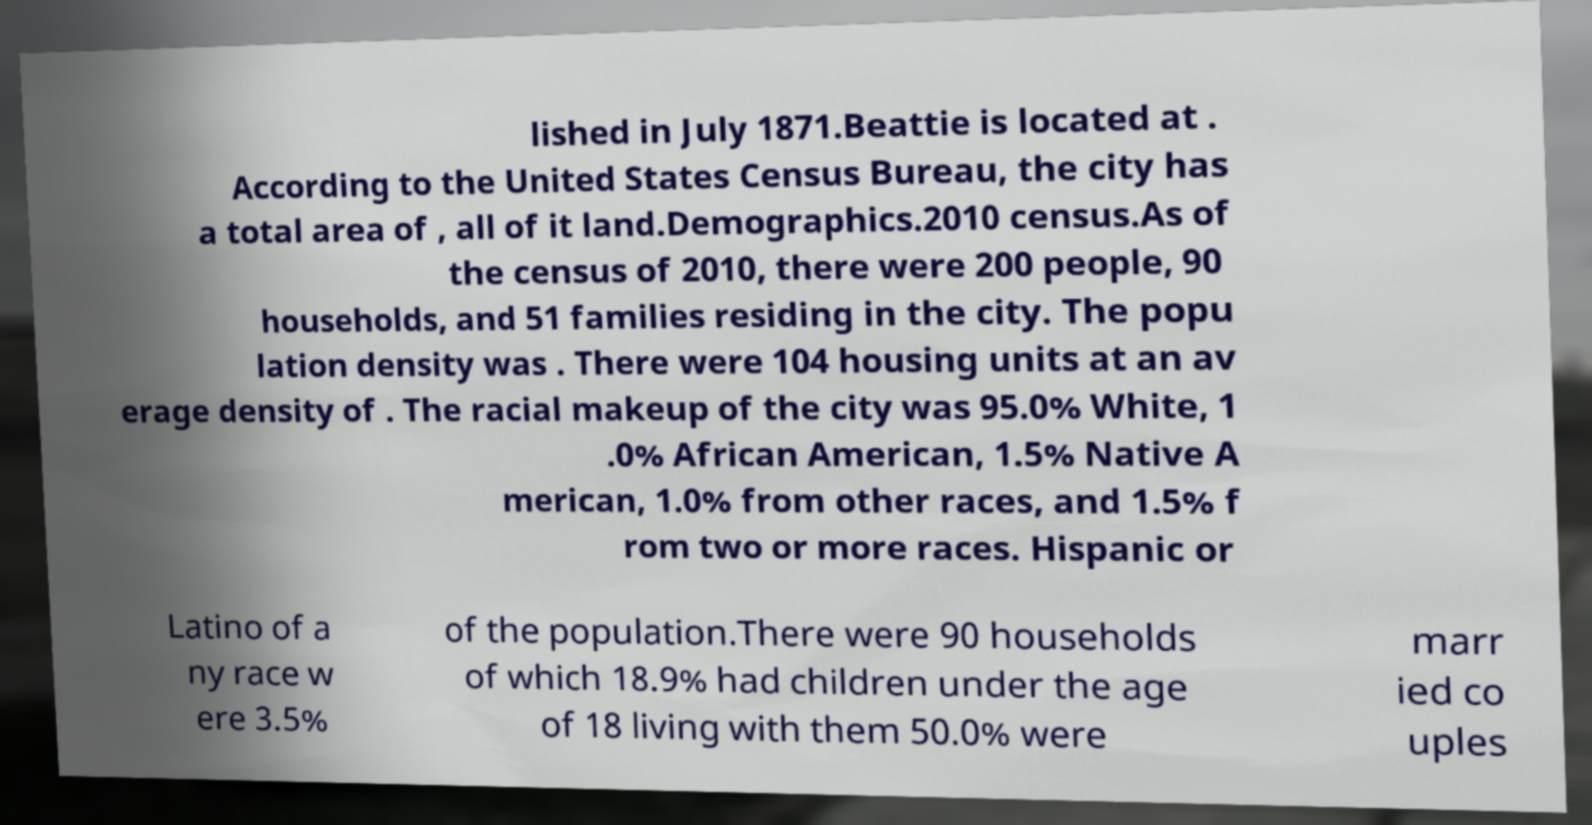Could you extract and type out the text from this image? lished in July 1871.Beattie is located at . According to the United States Census Bureau, the city has a total area of , all of it land.Demographics.2010 census.As of the census of 2010, there were 200 people, 90 households, and 51 families residing in the city. The popu lation density was . There were 104 housing units at an av erage density of . The racial makeup of the city was 95.0% White, 1 .0% African American, 1.5% Native A merican, 1.0% from other races, and 1.5% f rom two or more races. Hispanic or Latino of a ny race w ere 3.5% of the population.There were 90 households of which 18.9% had children under the age of 18 living with them 50.0% were marr ied co uples 